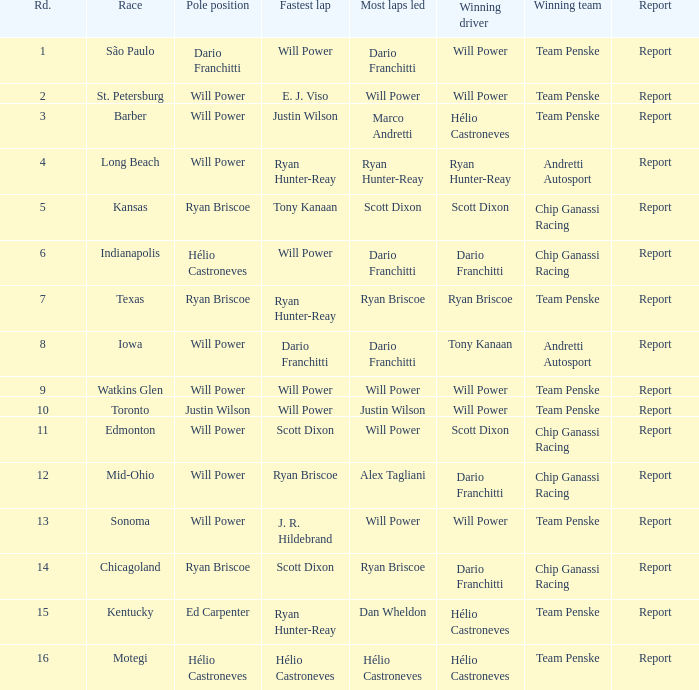In which position did the driver who won at chicagoland complete the race? 1.0. 